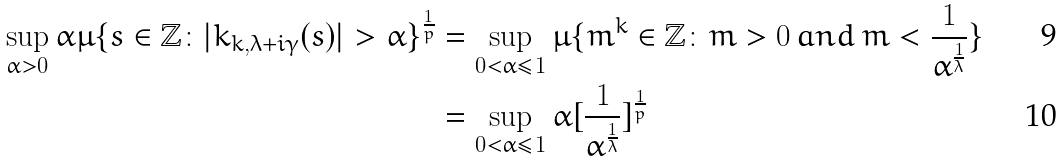Convert formula to latex. <formula><loc_0><loc_0><loc_500><loc_500>\sup _ { \alpha > 0 } \alpha \mu \{ s \in \mathbb { Z } \colon | k _ { k , \lambda + i \gamma } ( s ) | > \alpha \} ^ { \frac { 1 } { p } } & = \sup _ { 0 < \alpha \leq 1 } \mu \{ m ^ { k } \in \mathbb { Z } \colon m > 0 \, a n d \, m < \frac { 1 } { \alpha ^ { \frac { 1 } { \lambda } } } \} \\ & = \sup _ { 0 < \alpha \leq 1 } \alpha [ \frac { 1 } { \alpha ^ { \frac { 1 } { \lambda } } } ] ^ { \frac { 1 } { p } }</formula> 